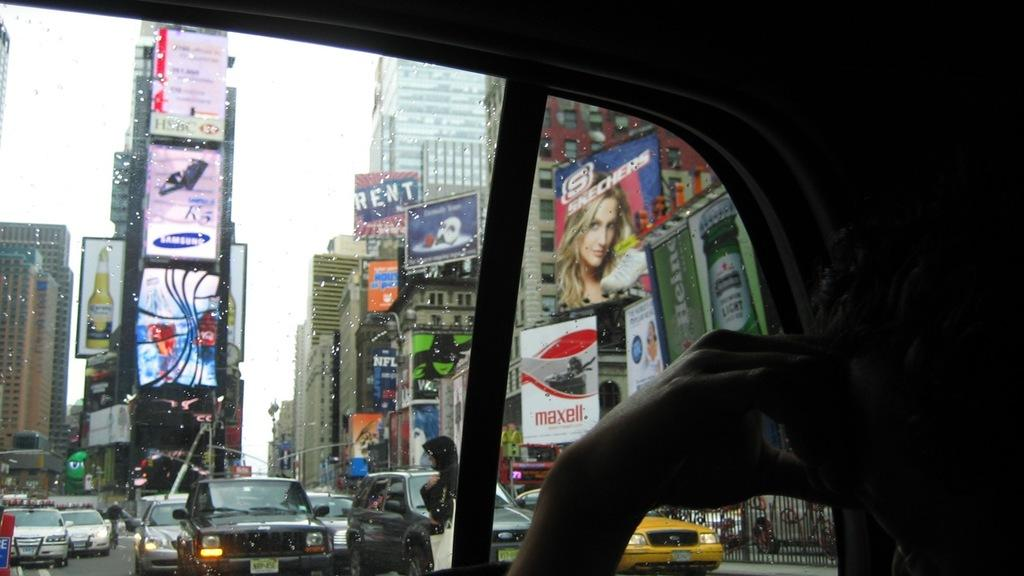<image>
Render a clear and concise summary of the photo. A busy city scene viewed from a car with buildings carrying adverts for Samsung and Maxell. 